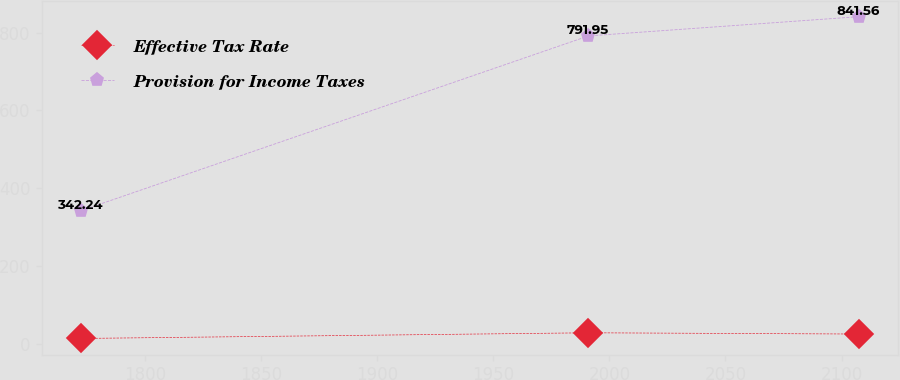Convert chart. <chart><loc_0><loc_0><loc_500><loc_500><line_chart><ecel><fcel>Effective Tax Rate<fcel>Provision for Income Taxes<nl><fcel>1772.55<fcel>13.19<fcel>342.24<nl><fcel>1991.01<fcel>27.79<fcel>791.95<nl><fcel>2107.57<fcel>24.56<fcel>841.56<nl></chart> 